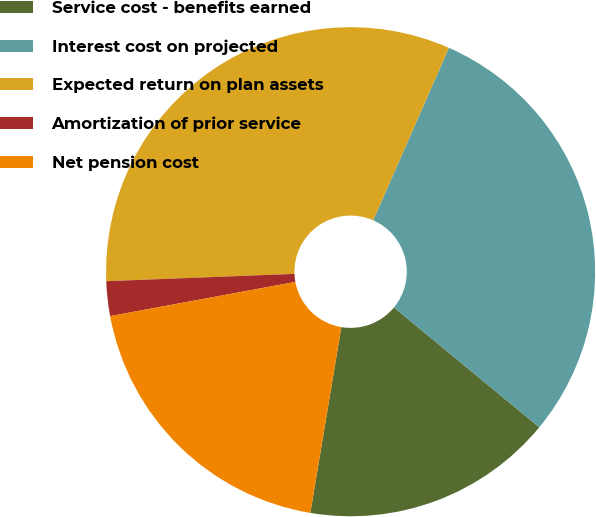<chart> <loc_0><loc_0><loc_500><loc_500><pie_chart><fcel>Service cost - benefits earned<fcel>Interest cost on projected<fcel>Expected return on plan assets<fcel>Amortization of prior service<fcel>Net pension cost<nl><fcel>16.66%<fcel>29.39%<fcel>32.2%<fcel>2.29%<fcel>19.46%<nl></chart> 